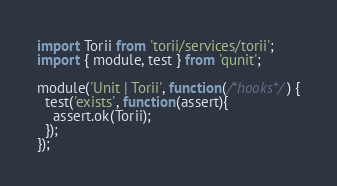Convert code to text. <code><loc_0><loc_0><loc_500><loc_500><_JavaScript_>import Torii from 'torii/services/torii';
import { module, test } from 'qunit';

module('Unit | Torii', function(/*hooks*/) {
  test('exists', function(assert){
    assert.ok(Torii);
  });
});
</code> 